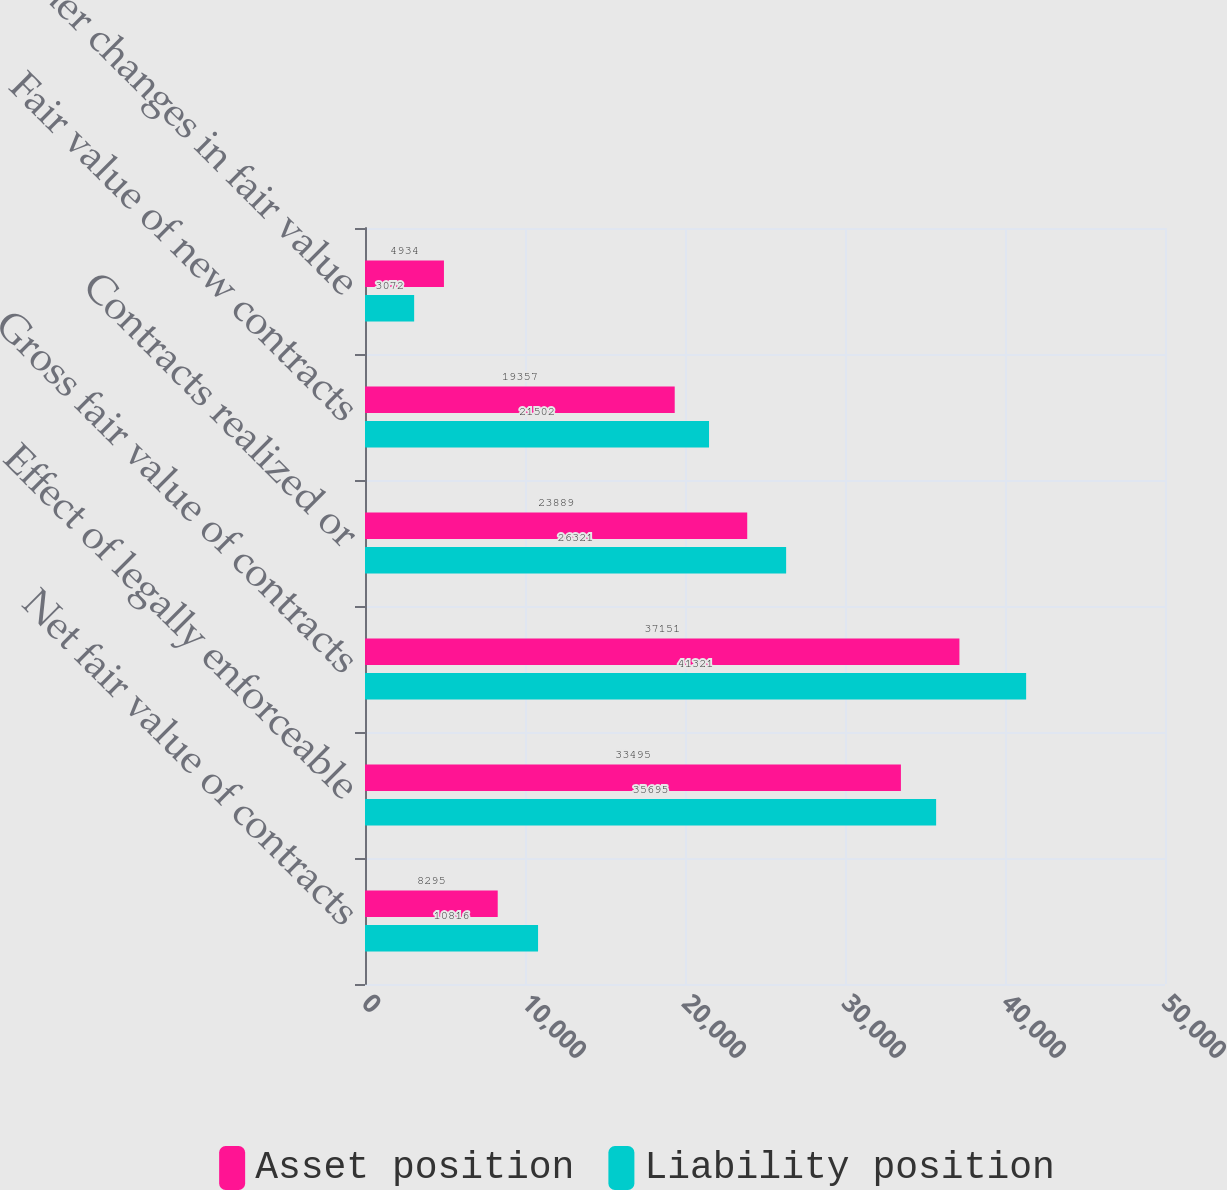Convert chart. <chart><loc_0><loc_0><loc_500><loc_500><stacked_bar_chart><ecel><fcel>Net fair value of contracts<fcel>Effect of legally enforceable<fcel>Gross fair value of contracts<fcel>Contracts realized or<fcel>Fair value of new contracts<fcel>Other changes in fair value<nl><fcel>Asset position<fcel>8295<fcel>33495<fcel>37151<fcel>23889<fcel>19357<fcel>4934<nl><fcel>Liability position<fcel>10816<fcel>35695<fcel>41321<fcel>26321<fcel>21502<fcel>3072<nl></chart> 